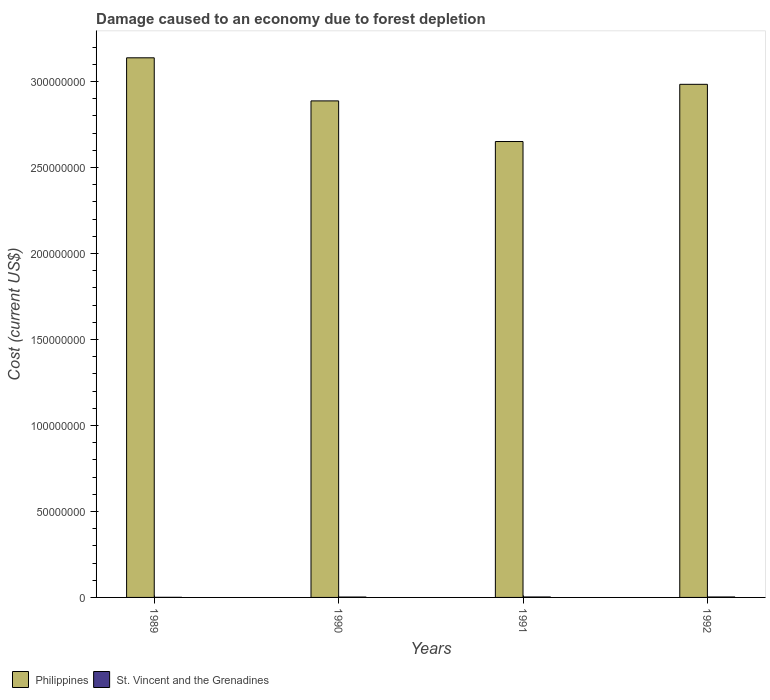How many groups of bars are there?
Make the answer very short. 4. In how many cases, is the number of bars for a given year not equal to the number of legend labels?
Make the answer very short. 0. What is the cost of damage caused due to forest depletion in St. Vincent and the Grenadines in 1990?
Your answer should be very brief. 2.22e+05. Across all years, what is the maximum cost of damage caused due to forest depletion in Philippines?
Provide a succinct answer. 3.14e+08. Across all years, what is the minimum cost of damage caused due to forest depletion in Philippines?
Your answer should be very brief. 2.65e+08. In which year was the cost of damage caused due to forest depletion in Philippines minimum?
Keep it short and to the point. 1991. What is the total cost of damage caused due to forest depletion in St. Vincent and the Grenadines in the graph?
Provide a succinct answer. 8.06e+05. What is the difference between the cost of damage caused due to forest depletion in Philippines in 1990 and that in 1991?
Make the answer very short. 2.36e+07. What is the difference between the cost of damage caused due to forest depletion in St. Vincent and the Grenadines in 1992 and the cost of damage caused due to forest depletion in Philippines in 1990?
Your answer should be very brief. -2.88e+08. What is the average cost of damage caused due to forest depletion in St. Vincent and the Grenadines per year?
Your answer should be compact. 2.02e+05. In the year 1992, what is the difference between the cost of damage caused due to forest depletion in St. Vincent and the Grenadines and cost of damage caused due to forest depletion in Philippines?
Provide a succinct answer. -2.98e+08. What is the ratio of the cost of damage caused due to forest depletion in St. Vincent and the Grenadines in 1989 to that in 1990?
Keep it short and to the point. 0.29. What is the difference between the highest and the second highest cost of damage caused due to forest depletion in Philippines?
Ensure brevity in your answer.  1.54e+07. What is the difference between the highest and the lowest cost of damage caused due to forest depletion in Philippines?
Provide a short and direct response. 4.87e+07. In how many years, is the cost of damage caused due to forest depletion in St. Vincent and the Grenadines greater than the average cost of damage caused due to forest depletion in St. Vincent and the Grenadines taken over all years?
Make the answer very short. 3. What does the 1st bar from the right in 1992 represents?
Offer a very short reply. St. Vincent and the Grenadines. How many bars are there?
Make the answer very short. 8. Are all the bars in the graph horizontal?
Offer a very short reply. No. What is the difference between two consecutive major ticks on the Y-axis?
Your response must be concise. 5.00e+07. Does the graph contain grids?
Provide a short and direct response. No. How many legend labels are there?
Keep it short and to the point. 2. How are the legend labels stacked?
Give a very brief answer. Horizontal. What is the title of the graph?
Provide a succinct answer. Damage caused to an economy due to forest depletion. Does "Maldives" appear as one of the legend labels in the graph?
Provide a succinct answer. No. What is the label or title of the X-axis?
Give a very brief answer. Years. What is the label or title of the Y-axis?
Your answer should be compact. Cost (current US$). What is the Cost (current US$) in Philippines in 1989?
Ensure brevity in your answer.  3.14e+08. What is the Cost (current US$) in St. Vincent and the Grenadines in 1989?
Your response must be concise. 6.39e+04. What is the Cost (current US$) of Philippines in 1990?
Offer a terse response. 2.89e+08. What is the Cost (current US$) of St. Vincent and the Grenadines in 1990?
Give a very brief answer. 2.22e+05. What is the Cost (current US$) in Philippines in 1991?
Give a very brief answer. 2.65e+08. What is the Cost (current US$) of St. Vincent and the Grenadines in 1991?
Provide a short and direct response. 2.62e+05. What is the Cost (current US$) of Philippines in 1992?
Keep it short and to the point. 2.98e+08. What is the Cost (current US$) in St. Vincent and the Grenadines in 1992?
Ensure brevity in your answer.  2.59e+05. Across all years, what is the maximum Cost (current US$) of Philippines?
Offer a very short reply. 3.14e+08. Across all years, what is the maximum Cost (current US$) of St. Vincent and the Grenadines?
Your response must be concise. 2.62e+05. Across all years, what is the minimum Cost (current US$) in Philippines?
Your answer should be very brief. 2.65e+08. Across all years, what is the minimum Cost (current US$) in St. Vincent and the Grenadines?
Make the answer very short. 6.39e+04. What is the total Cost (current US$) in Philippines in the graph?
Give a very brief answer. 1.17e+09. What is the total Cost (current US$) in St. Vincent and the Grenadines in the graph?
Offer a terse response. 8.06e+05. What is the difference between the Cost (current US$) in Philippines in 1989 and that in 1990?
Offer a terse response. 2.51e+07. What is the difference between the Cost (current US$) of St. Vincent and the Grenadines in 1989 and that in 1990?
Provide a succinct answer. -1.58e+05. What is the difference between the Cost (current US$) of Philippines in 1989 and that in 1991?
Your response must be concise. 4.87e+07. What is the difference between the Cost (current US$) of St. Vincent and the Grenadines in 1989 and that in 1991?
Your answer should be very brief. -1.98e+05. What is the difference between the Cost (current US$) of Philippines in 1989 and that in 1992?
Ensure brevity in your answer.  1.54e+07. What is the difference between the Cost (current US$) of St. Vincent and the Grenadines in 1989 and that in 1992?
Provide a succinct answer. -1.95e+05. What is the difference between the Cost (current US$) of Philippines in 1990 and that in 1991?
Provide a short and direct response. 2.36e+07. What is the difference between the Cost (current US$) of St. Vincent and the Grenadines in 1990 and that in 1991?
Your answer should be very brief. -4.03e+04. What is the difference between the Cost (current US$) in Philippines in 1990 and that in 1992?
Offer a terse response. -9.65e+06. What is the difference between the Cost (current US$) of St. Vincent and the Grenadines in 1990 and that in 1992?
Make the answer very short. -3.73e+04. What is the difference between the Cost (current US$) in Philippines in 1991 and that in 1992?
Keep it short and to the point. -3.33e+07. What is the difference between the Cost (current US$) in St. Vincent and the Grenadines in 1991 and that in 1992?
Provide a short and direct response. 2986.18. What is the difference between the Cost (current US$) of Philippines in 1989 and the Cost (current US$) of St. Vincent and the Grenadines in 1990?
Give a very brief answer. 3.14e+08. What is the difference between the Cost (current US$) of Philippines in 1989 and the Cost (current US$) of St. Vincent and the Grenadines in 1991?
Your answer should be compact. 3.13e+08. What is the difference between the Cost (current US$) of Philippines in 1989 and the Cost (current US$) of St. Vincent and the Grenadines in 1992?
Provide a succinct answer. 3.13e+08. What is the difference between the Cost (current US$) of Philippines in 1990 and the Cost (current US$) of St. Vincent and the Grenadines in 1991?
Offer a terse response. 2.88e+08. What is the difference between the Cost (current US$) of Philippines in 1990 and the Cost (current US$) of St. Vincent and the Grenadines in 1992?
Provide a succinct answer. 2.88e+08. What is the difference between the Cost (current US$) of Philippines in 1991 and the Cost (current US$) of St. Vincent and the Grenadines in 1992?
Ensure brevity in your answer.  2.65e+08. What is the average Cost (current US$) in Philippines per year?
Offer a terse response. 2.91e+08. What is the average Cost (current US$) in St. Vincent and the Grenadines per year?
Keep it short and to the point. 2.02e+05. In the year 1989, what is the difference between the Cost (current US$) in Philippines and Cost (current US$) in St. Vincent and the Grenadines?
Keep it short and to the point. 3.14e+08. In the year 1990, what is the difference between the Cost (current US$) in Philippines and Cost (current US$) in St. Vincent and the Grenadines?
Your answer should be very brief. 2.88e+08. In the year 1991, what is the difference between the Cost (current US$) in Philippines and Cost (current US$) in St. Vincent and the Grenadines?
Give a very brief answer. 2.65e+08. In the year 1992, what is the difference between the Cost (current US$) of Philippines and Cost (current US$) of St. Vincent and the Grenadines?
Ensure brevity in your answer.  2.98e+08. What is the ratio of the Cost (current US$) in Philippines in 1989 to that in 1990?
Your response must be concise. 1.09. What is the ratio of the Cost (current US$) of St. Vincent and the Grenadines in 1989 to that in 1990?
Your answer should be very brief. 0.29. What is the ratio of the Cost (current US$) of Philippines in 1989 to that in 1991?
Your response must be concise. 1.18. What is the ratio of the Cost (current US$) in St. Vincent and the Grenadines in 1989 to that in 1991?
Offer a very short reply. 0.24. What is the ratio of the Cost (current US$) in Philippines in 1989 to that in 1992?
Provide a succinct answer. 1.05. What is the ratio of the Cost (current US$) in St. Vincent and the Grenadines in 1989 to that in 1992?
Offer a very short reply. 0.25. What is the ratio of the Cost (current US$) of Philippines in 1990 to that in 1991?
Your response must be concise. 1.09. What is the ratio of the Cost (current US$) of St. Vincent and the Grenadines in 1990 to that in 1991?
Give a very brief answer. 0.85. What is the ratio of the Cost (current US$) of Philippines in 1990 to that in 1992?
Ensure brevity in your answer.  0.97. What is the ratio of the Cost (current US$) of St. Vincent and the Grenadines in 1990 to that in 1992?
Your answer should be compact. 0.86. What is the ratio of the Cost (current US$) of Philippines in 1991 to that in 1992?
Provide a succinct answer. 0.89. What is the ratio of the Cost (current US$) of St. Vincent and the Grenadines in 1991 to that in 1992?
Keep it short and to the point. 1.01. What is the difference between the highest and the second highest Cost (current US$) of Philippines?
Offer a terse response. 1.54e+07. What is the difference between the highest and the second highest Cost (current US$) of St. Vincent and the Grenadines?
Keep it short and to the point. 2986.18. What is the difference between the highest and the lowest Cost (current US$) of Philippines?
Offer a terse response. 4.87e+07. What is the difference between the highest and the lowest Cost (current US$) in St. Vincent and the Grenadines?
Ensure brevity in your answer.  1.98e+05. 